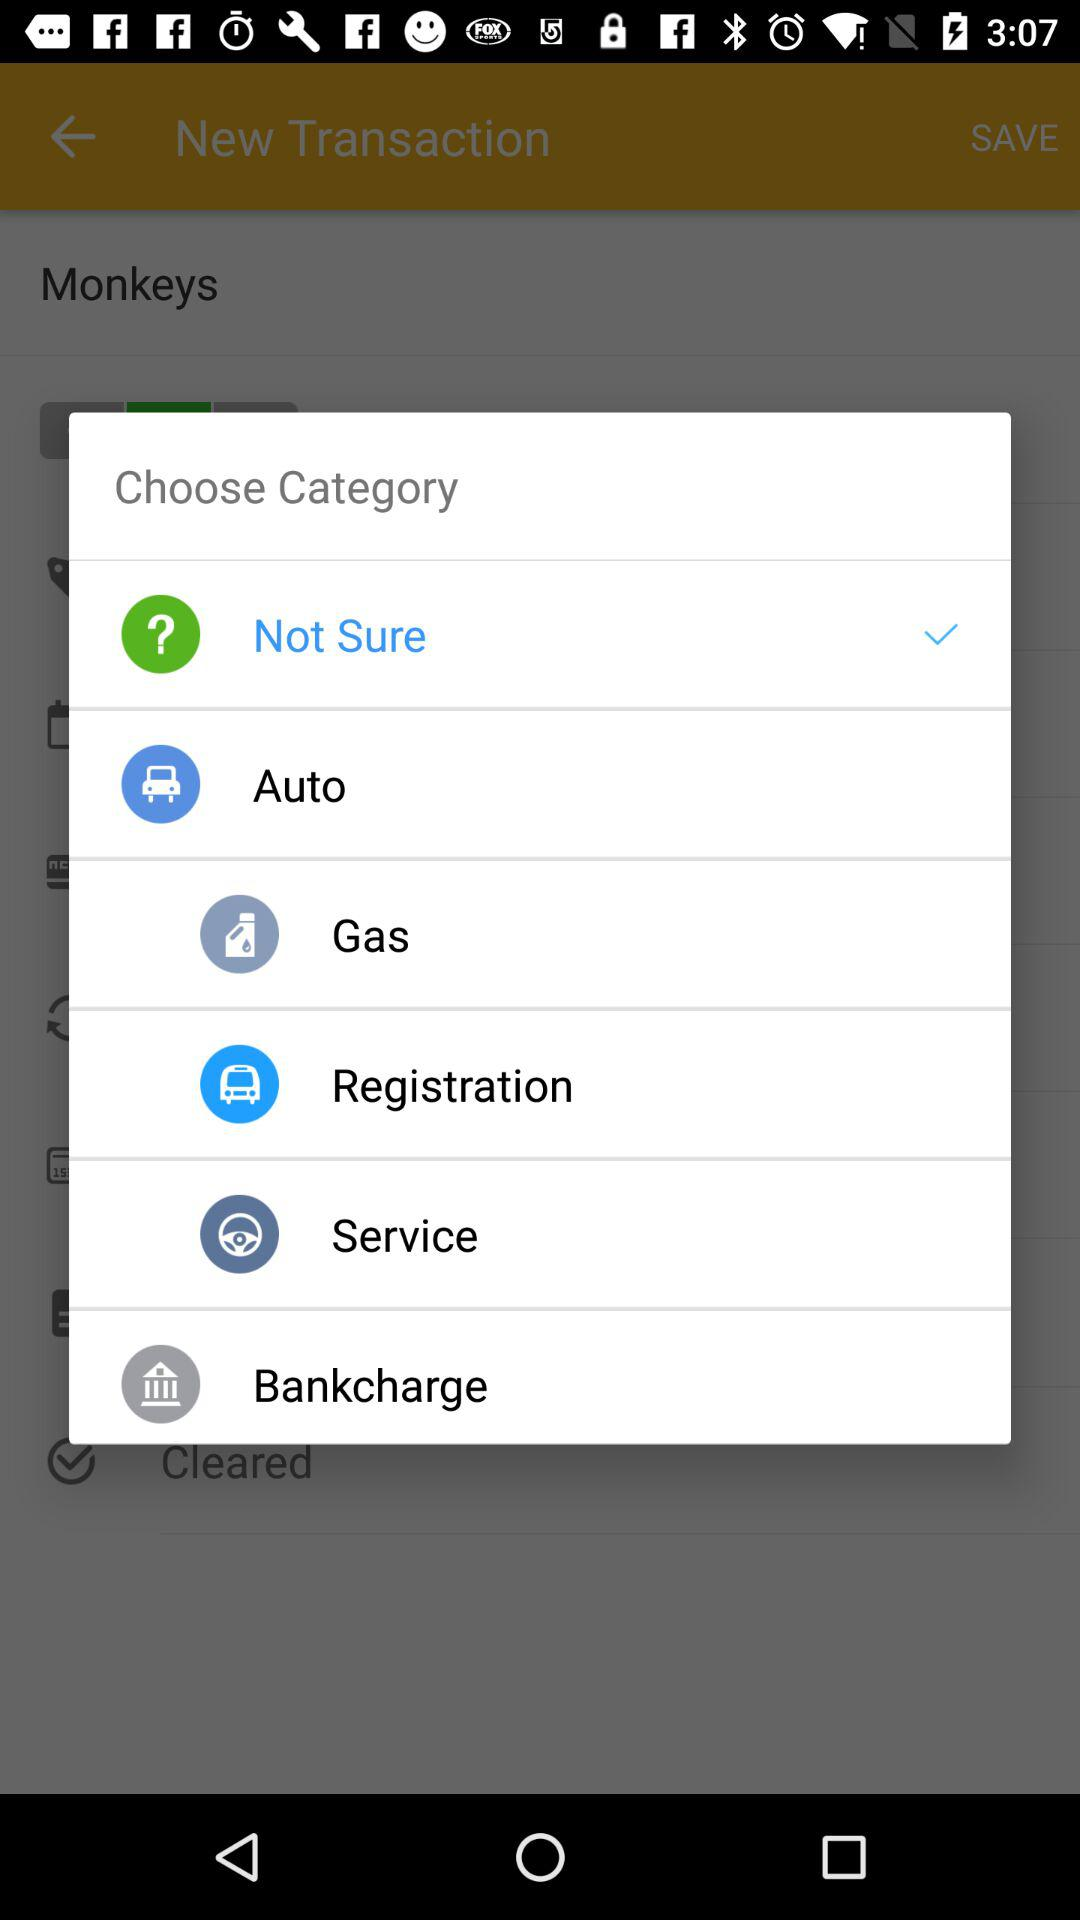How many categories are there?
Answer the question using a single word or phrase. 6 